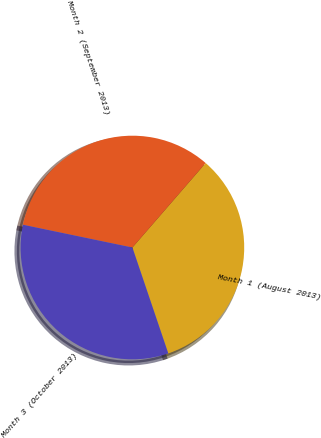<chart> <loc_0><loc_0><loc_500><loc_500><pie_chart><fcel>Month 1 (August 2013)<fcel>Month 2 (September 2013)<fcel>Month 3 (October 2013)<nl><fcel>33.43%<fcel>33.1%<fcel>33.46%<nl></chart> 